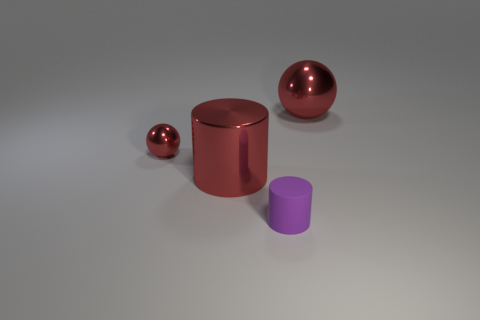Add 1 tiny red shiny balls. How many objects exist? 5 Subtract 2 balls. How many balls are left? 0 Subtract all cyan cylinders. Subtract all cyan balls. How many cylinders are left? 2 Subtract all cyan blocks. How many purple cylinders are left? 1 Subtract all large yellow metal balls. Subtract all purple matte cylinders. How many objects are left? 3 Add 4 small spheres. How many small spheres are left? 5 Add 1 small green matte cylinders. How many small green matte cylinders exist? 1 Subtract all red cylinders. How many cylinders are left? 1 Subtract 1 red balls. How many objects are left? 3 